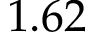<formula> <loc_0><loc_0><loc_500><loc_500>1 . 6 2</formula> 